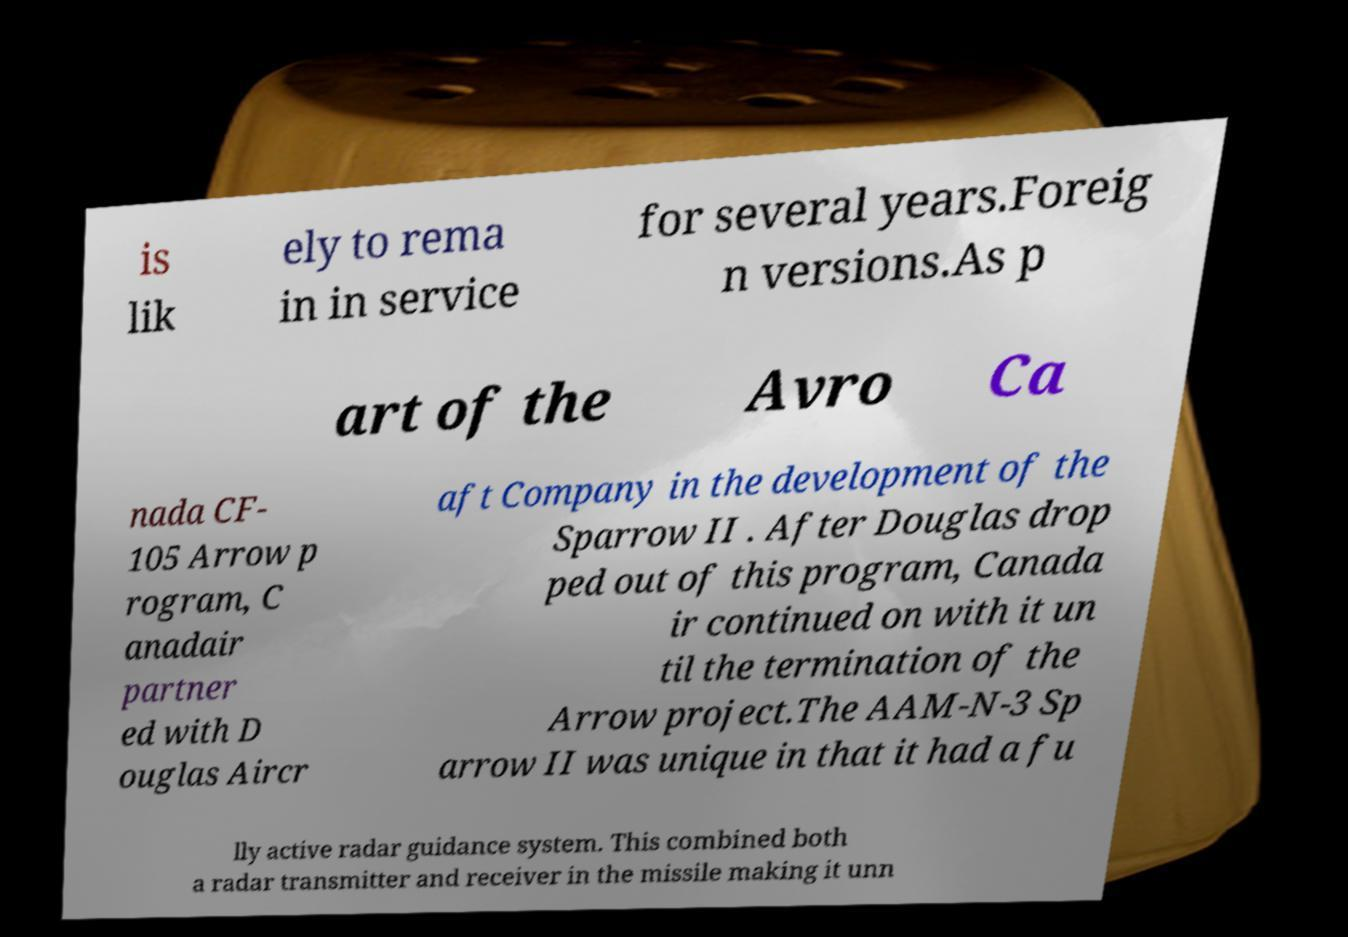Can you accurately transcribe the text from the provided image for me? is lik ely to rema in in service for several years.Foreig n versions.As p art of the Avro Ca nada CF- 105 Arrow p rogram, C anadair partner ed with D ouglas Aircr aft Company in the development of the Sparrow II . After Douglas drop ped out of this program, Canada ir continued on with it un til the termination of the Arrow project.The AAM-N-3 Sp arrow II was unique in that it had a fu lly active radar guidance system. This combined both a radar transmitter and receiver in the missile making it unn 